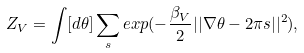<formula> <loc_0><loc_0><loc_500><loc_500>Z _ { V } = \int [ d \theta ] \sum _ { s } e x p ( - \frac { \beta _ { V } } { 2 } | | \nabla \theta - 2 \pi s | | ^ { 2 } ) ,</formula> 